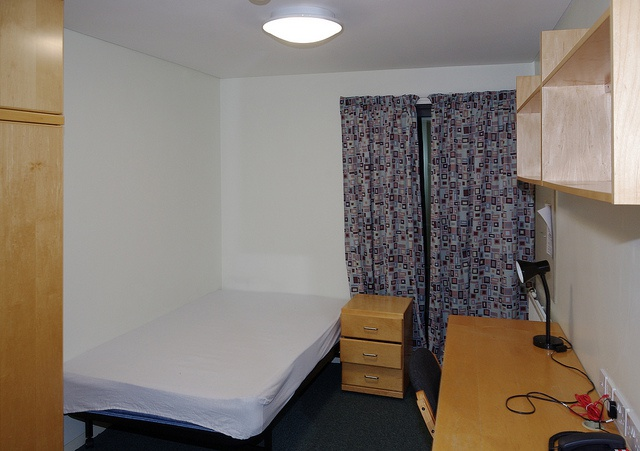Describe the objects in this image and their specific colors. I can see bed in gray, darkgray, and black tones and chair in gray, black, tan, and olive tones in this image. 